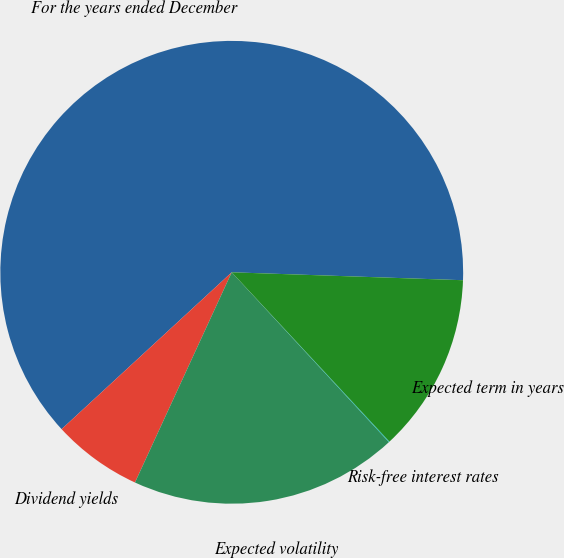Convert chart to OTSL. <chart><loc_0><loc_0><loc_500><loc_500><pie_chart><fcel>For the years ended December<fcel>Dividend yields<fcel>Expected volatility<fcel>Risk-free interest rates<fcel>Expected term in years<nl><fcel>62.4%<fcel>6.28%<fcel>18.75%<fcel>0.05%<fcel>12.52%<nl></chart> 